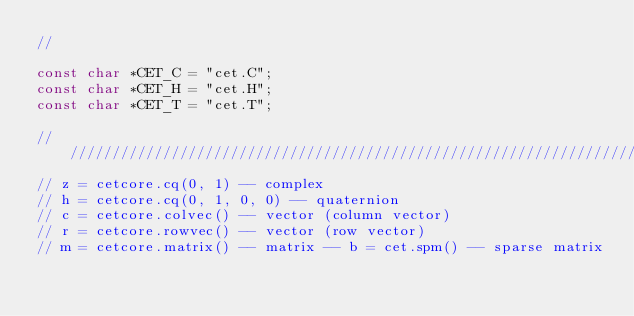Convert code to text. <code><loc_0><loc_0><loc_500><loc_500><_C++_>//

const char *CET_C = "cet.C";
const char *CET_H = "cet.H";
const char *CET_T = "cet.T";

///////////////////////////////////////////////////////////////////////////////
// z = cetcore.cq(0, 1) -- complex
// h = cetcore.cq(0, 1, 0, 0) -- quaternion
// c = cetcore.colvec() -- vector (column vector)
// r = cetcore.rowvec() -- vector (row vector)
// m = cetcore.matrix() -- matrix -- b = cet.spm() -- sparse matrix</code> 